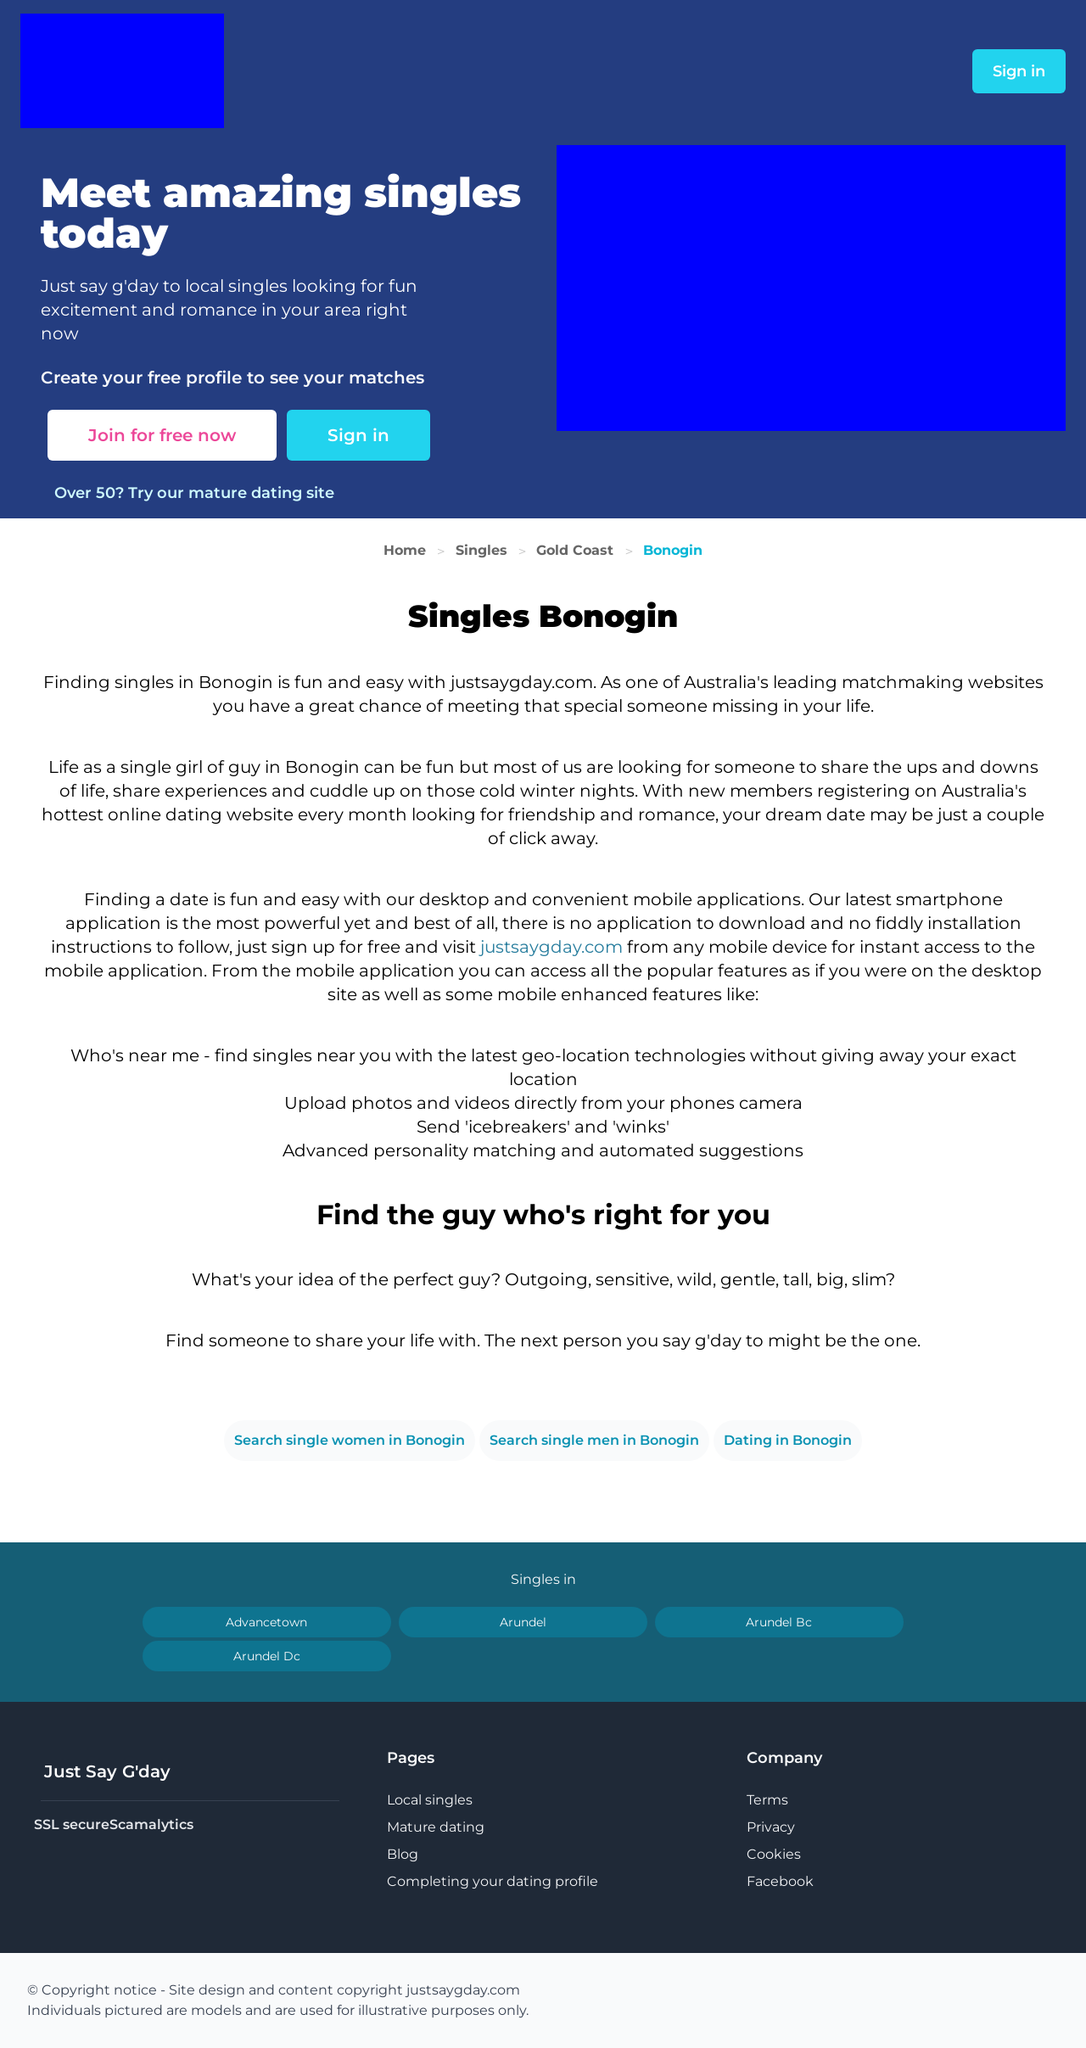What strategies can this website use to increase user engagement? To increase user engagement, the website can integrate more interactive features such as virtual events, forums, or group chats where users can discuss common interests. Also, offering personalized dating advice or blog posts that cater to relationship tips can drive deeper user interaction. Furthermore, implementing a rewards system for active participation could enhance user involvement significantly.  Can this service integrate social media features to enhance connectivity? Yes, integrating social media features would significantly enhance connectivity. Allowing users to link their profiles with social media could enable easier sharing of updates and connect friends or interests quickly. Features like 'Login with Facebook' or 'Share your date' can make the platform more accessible and encourage wider social interaction. 